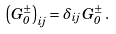<formula> <loc_0><loc_0><loc_500><loc_500>\left ( G _ { 0 } ^ { \pm } \right ) _ { i j } = \delta _ { i j } \, G _ { 0 } ^ { \pm } \, .</formula> 